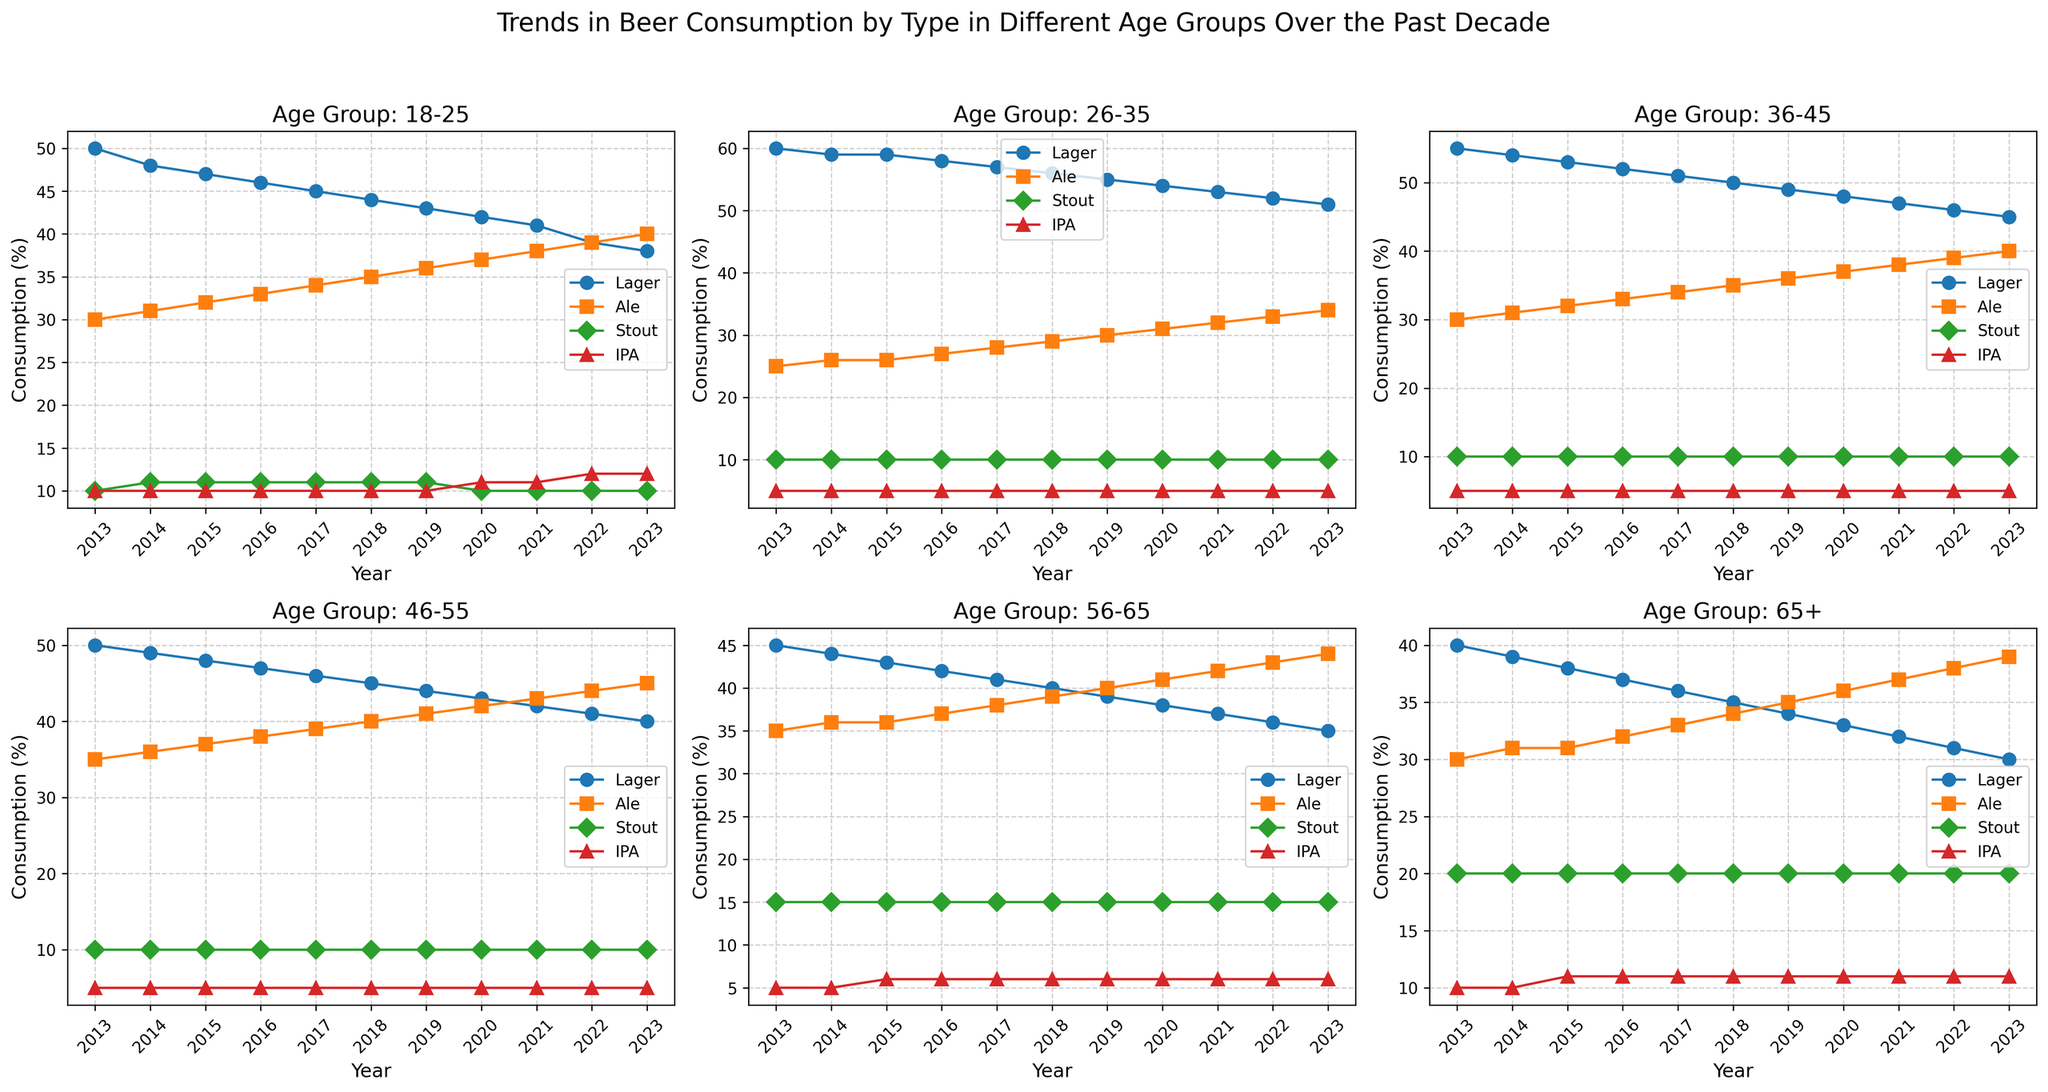Which age group had the highest Lager consumption in 2023? To find the age group with the highest Lager consumption in 2023, look at the points for Lager on each subplot corresponding to each age group for the year 2023. The 26-35 age group has the highest Lager consumption.
Answer: 26-35 How did IPA consumption change over the decade for the 18-25 age group? Observe the IPA line within the 18-25 age group subplot from 2013 to 2023. It starts at 10 in 2013 and ends at 12 in 2023. The change is an increase of 2 percentage points.
Answer: Increased by 2 percentage points In which year did Ale consumption surpass Lager consumption for the 46-55 age group? Inspect the points for Ale and Lager lines within the 46-55 age group subplot. Notice that in no year does Ale consumption surpass Lager consumption for this age group.
Answer: Never Which age group showed the most significant increase in Ale consumption from 2013 to 2023? Calculate the difference in Ale consumption from 2013 to 2023 for each age group. The 65+ age group increased Ale consumption from 30 in 2013 to 39 in 2023, an increase of 9 percentage points, which is the most significant.
Answer: 65+ How does Stout consumption in 2023 compare across all age groups? Look at the points for Stout in 2023 across all subplots. Each age group has the same Stout consumption of 10 except for the 56-65 and 65+ age groups, which have 15 and 20, respectively.
Answer: Highest for 65+ What is the average Lager consumption for the 26-35 age group over the decade? Sum the Lager consumption values for the 26-35 age group from 2013 to 2023 and divide by the number of years (11). (60+59+59+58+57+56+55+54+53+52+51)/11 = 56.45
Answer: 56.45 Between which years did the 56-65 age group see the most significant increase in Ale consumption? Look at the Ale values on the 56-65 age group subplot. The most significant increase happens between 2015 and 2016 from 36 to 37.
Answer: 2015 to 2016 Which beer type saw a consistent increase in consumption for the 18-25 age group from 2013 to 2023? Examine the lines for each beer type in the 18-25 age group subplot. The Ale consumption line shows a consistent increase from 30 in 2013 to 40 in 2023.
Answer: Ale 